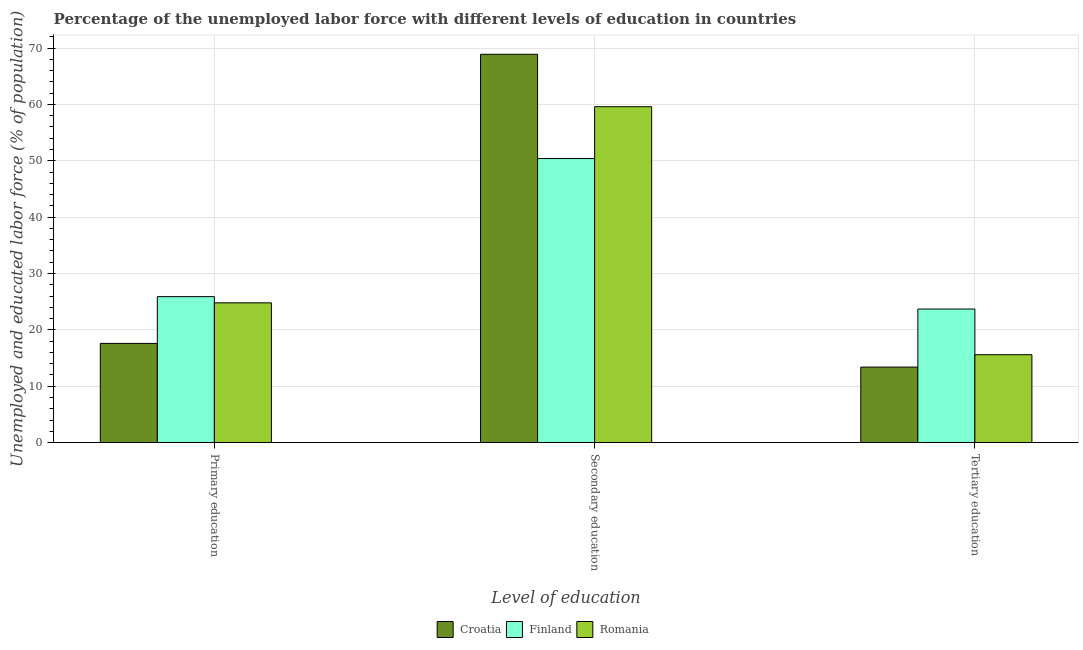Are the number of bars per tick equal to the number of legend labels?
Keep it short and to the point. Yes. Are the number of bars on each tick of the X-axis equal?
Provide a short and direct response. Yes. How many bars are there on the 1st tick from the right?
Your answer should be compact. 3. What is the percentage of labor force who received secondary education in Romania?
Offer a very short reply. 59.6. Across all countries, what is the maximum percentage of labor force who received primary education?
Ensure brevity in your answer.  25.9. Across all countries, what is the minimum percentage of labor force who received tertiary education?
Make the answer very short. 13.4. In which country was the percentage of labor force who received secondary education maximum?
Make the answer very short. Croatia. In which country was the percentage of labor force who received primary education minimum?
Provide a short and direct response. Croatia. What is the total percentage of labor force who received tertiary education in the graph?
Make the answer very short. 52.7. What is the difference between the percentage of labor force who received tertiary education in Finland and that in Romania?
Make the answer very short. 8.1. What is the difference between the percentage of labor force who received primary education in Croatia and the percentage of labor force who received tertiary education in Romania?
Provide a short and direct response. 2. What is the average percentage of labor force who received secondary education per country?
Your response must be concise. 59.63. What is the difference between the percentage of labor force who received primary education and percentage of labor force who received secondary education in Croatia?
Your answer should be very brief. -51.3. What is the ratio of the percentage of labor force who received secondary education in Romania to that in Croatia?
Provide a succinct answer. 0.87. Is the percentage of labor force who received primary education in Finland less than that in Croatia?
Make the answer very short. No. What is the difference between the highest and the second highest percentage of labor force who received secondary education?
Provide a succinct answer. 9.3. What is the difference between the highest and the lowest percentage of labor force who received secondary education?
Ensure brevity in your answer.  18.5. Is the sum of the percentage of labor force who received primary education in Croatia and Romania greater than the maximum percentage of labor force who received secondary education across all countries?
Your response must be concise. No. What does the 3rd bar from the right in Primary education represents?
Your answer should be very brief. Croatia. Is it the case that in every country, the sum of the percentage of labor force who received primary education and percentage of labor force who received secondary education is greater than the percentage of labor force who received tertiary education?
Keep it short and to the point. Yes. Are all the bars in the graph horizontal?
Ensure brevity in your answer.  No. How many countries are there in the graph?
Provide a short and direct response. 3. What is the difference between two consecutive major ticks on the Y-axis?
Your answer should be compact. 10. Are the values on the major ticks of Y-axis written in scientific E-notation?
Provide a short and direct response. No. Does the graph contain any zero values?
Make the answer very short. No. Does the graph contain grids?
Your answer should be compact. Yes. Where does the legend appear in the graph?
Ensure brevity in your answer.  Bottom center. How are the legend labels stacked?
Your response must be concise. Horizontal. What is the title of the graph?
Offer a very short reply. Percentage of the unemployed labor force with different levels of education in countries. Does "Israel" appear as one of the legend labels in the graph?
Keep it short and to the point. No. What is the label or title of the X-axis?
Provide a short and direct response. Level of education. What is the label or title of the Y-axis?
Offer a terse response. Unemployed and educated labor force (% of population). What is the Unemployed and educated labor force (% of population) in Croatia in Primary education?
Offer a very short reply. 17.6. What is the Unemployed and educated labor force (% of population) of Finland in Primary education?
Ensure brevity in your answer.  25.9. What is the Unemployed and educated labor force (% of population) of Romania in Primary education?
Your response must be concise. 24.8. What is the Unemployed and educated labor force (% of population) in Croatia in Secondary education?
Make the answer very short. 68.9. What is the Unemployed and educated labor force (% of population) in Finland in Secondary education?
Your answer should be compact. 50.4. What is the Unemployed and educated labor force (% of population) in Romania in Secondary education?
Make the answer very short. 59.6. What is the Unemployed and educated labor force (% of population) of Croatia in Tertiary education?
Your response must be concise. 13.4. What is the Unemployed and educated labor force (% of population) of Finland in Tertiary education?
Keep it short and to the point. 23.7. What is the Unemployed and educated labor force (% of population) in Romania in Tertiary education?
Make the answer very short. 15.6. Across all Level of education, what is the maximum Unemployed and educated labor force (% of population) of Croatia?
Provide a short and direct response. 68.9. Across all Level of education, what is the maximum Unemployed and educated labor force (% of population) of Finland?
Ensure brevity in your answer.  50.4. Across all Level of education, what is the maximum Unemployed and educated labor force (% of population) in Romania?
Give a very brief answer. 59.6. Across all Level of education, what is the minimum Unemployed and educated labor force (% of population) of Croatia?
Provide a short and direct response. 13.4. Across all Level of education, what is the minimum Unemployed and educated labor force (% of population) in Finland?
Make the answer very short. 23.7. Across all Level of education, what is the minimum Unemployed and educated labor force (% of population) of Romania?
Your response must be concise. 15.6. What is the total Unemployed and educated labor force (% of population) of Croatia in the graph?
Your response must be concise. 99.9. What is the total Unemployed and educated labor force (% of population) of Finland in the graph?
Give a very brief answer. 100. What is the total Unemployed and educated labor force (% of population) of Romania in the graph?
Make the answer very short. 100. What is the difference between the Unemployed and educated labor force (% of population) of Croatia in Primary education and that in Secondary education?
Give a very brief answer. -51.3. What is the difference between the Unemployed and educated labor force (% of population) of Finland in Primary education and that in Secondary education?
Keep it short and to the point. -24.5. What is the difference between the Unemployed and educated labor force (% of population) of Romania in Primary education and that in Secondary education?
Offer a very short reply. -34.8. What is the difference between the Unemployed and educated labor force (% of population) of Croatia in Primary education and that in Tertiary education?
Ensure brevity in your answer.  4.2. What is the difference between the Unemployed and educated labor force (% of population) of Finland in Primary education and that in Tertiary education?
Ensure brevity in your answer.  2.2. What is the difference between the Unemployed and educated labor force (% of population) of Romania in Primary education and that in Tertiary education?
Offer a very short reply. 9.2. What is the difference between the Unemployed and educated labor force (% of population) of Croatia in Secondary education and that in Tertiary education?
Make the answer very short. 55.5. What is the difference between the Unemployed and educated labor force (% of population) in Finland in Secondary education and that in Tertiary education?
Ensure brevity in your answer.  26.7. What is the difference between the Unemployed and educated labor force (% of population) of Croatia in Primary education and the Unemployed and educated labor force (% of population) of Finland in Secondary education?
Provide a succinct answer. -32.8. What is the difference between the Unemployed and educated labor force (% of population) of Croatia in Primary education and the Unemployed and educated labor force (% of population) of Romania in Secondary education?
Your answer should be compact. -42. What is the difference between the Unemployed and educated labor force (% of population) of Finland in Primary education and the Unemployed and educated labor force (% of population) of Romania in Secondary education?
Offer a very short reply. -33.7. What is the difference between the Unemployed and educated labor force (% of population) of Croatia in Primary education and the Unemployed and educated labor force (% of population) of Finland in Tertiary education?
Make the answer very short. -6.1. What is the difference between the Unemployed and educated labor force (% of population) in Croatia in Primary education and the Unemployed and educated labor force (% of population) in Romania in Tertiary education?
Offer a very short reply. 2. What is the difference between the Unemployed and educated labor force (% of population) in Croatia in Secondary education and the Unemployed and educated labor force (% of population) in Finland in Tertiary education?
Keep it short and to the point. 45.2. What is the difference between the Unemployed and educated labor force (% of population) of Croatia in Secondary education and the Unemployed and educated labor force (% of population) of Romania in Tertiary education?
Provide a short and direct response. 53.3. What is the difference between the Unemployed and educated labor force (% of population) of Finland in Secondary education and the Unemployed and educated labor force (% of population) of Romania in Tertiary education?
Keep it short and to the point. 34.8. What is the average Unemployed and educated labor force (% of population) of Croatia per Level of education?
Your response must be concise. 33.3. What is the average Unemployed and educated labor force (% of population) in Finland per Level of education?
Ensure brevity in your answer.  33.33. What is the average Unemployed and educated labor force (% of population) of Romania per Level of education?
Provide a short and direct response. 33.33. What is the difference between the Unemployed and educated labor force (% of population) of Croatia and Unemployed and educated labor force (% of population) of Romania in Primary education?
Your response must be concise. -7.2. What is the difference between the Unemployed and educated labor force (% of population) in Finland and Unemployed and educated labor force (% of population) in Romania in Secondary education?
Provide a succinct answer. -9.2. What is the difference between the Unemployed and educated labor force (% of population) in Croatia and Unemployed and educated labor force (% of population) in Finland in Tertiary education?
Your answer should be very brief. -10.3. What is the difference between the Unemployed and educated labor force (% of population) of Finland and Unemployed and educated labor force (% of population) of Romania in Tertiary education?
Provide a short and direct response. 8.1. What is the ratio of the Unemployed and educated labor force (% of population) of Croatia in Primary education to that in Secondary education?
Offer a very short reply. 0.26. What is the ratio of the Unemployed and educated labor force (% of population) in Finland in Primary education to that in Secondary education?
Make the answer very short. 0.51. What is the ratio of the Unemployed and educated labor force (% of population) of Romania in Primary education to that in Secondary education?
Give a very brief answer. 0.42. What is the ratio of the Unemployed and educated labor force (% of population) of Croatia in Primary education to that in Tertiary education?
Provide a succinct answer. 1.31. What is the ratio of the Unemployed and educated labor force (% of population) in Finland in Primary education to that in Tertiary education?
Make the answer very short. 1.09. What is the ratio of the Unemployed and educated labor force (% of population) in Romania in Primary education to that in Tertiary education?
Offer a terse response. 1.59. What is the ratio of the Unemployed and educated labor force (% of population) of Croatia in Secondary education to that in Tertiary education?
Provide a short and direct response. 5.14. What is the ratio of the Unemployed and educated labor force (% of population) of Finland in Secondary education to that in Tertiary education?
Provide a succinct answer. 2.13. What is the ratio of the Unemployed and educated labor force (% of population) in Romania in Secondary education to that in Tertiary education?
Provide a short and direct response. 3.82. What is the difference between the highest and the second highest Unemployed and educated labor force (% of population) in Croatia?
Your answer should be very brief. 51.3. What is the difference between the highest and the second highest Unemployed and educated labor force (% of population) in Romania?
Make the answer very short. 34.8. What is the difference between the highest and the lowest Unemployed and educated labor force (% of population) of Croatia?
Provide a succinct answer. 55.5. What is the difference between the highest and the lowest Unemployed and educated labor force (% of population) in Finland?
Keep it short and to the point. 26.7. 